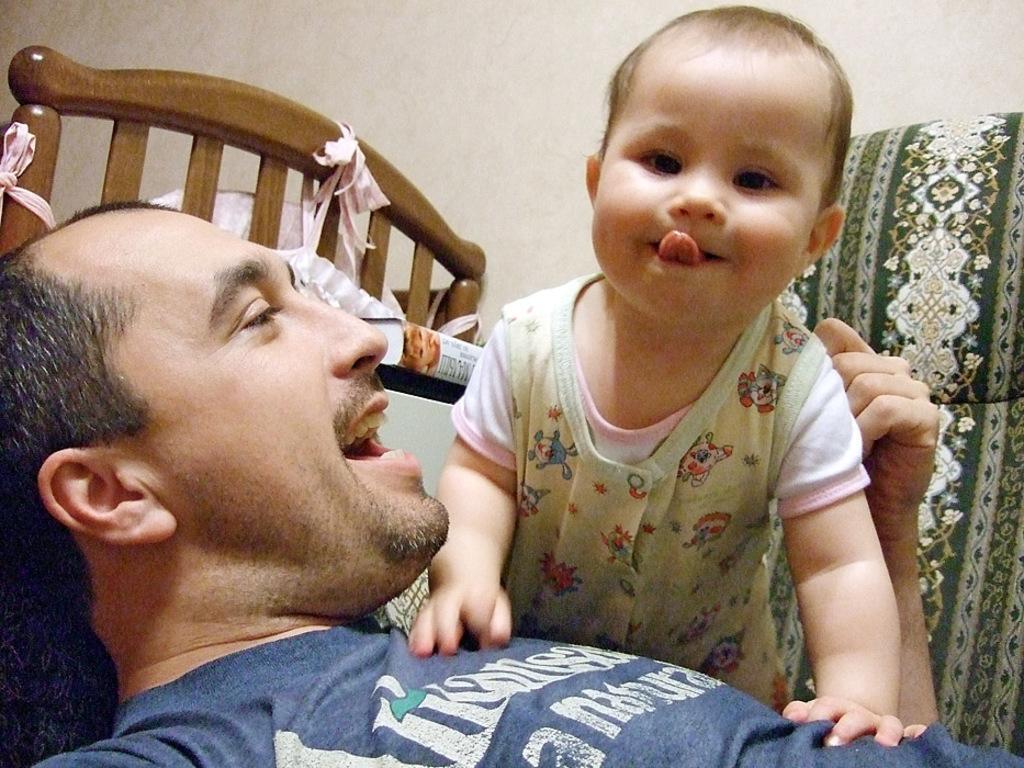Could you give a brief overview of what you see in this image? In the center of the image we can see man and kid on the bed. In the background we can see wall. 